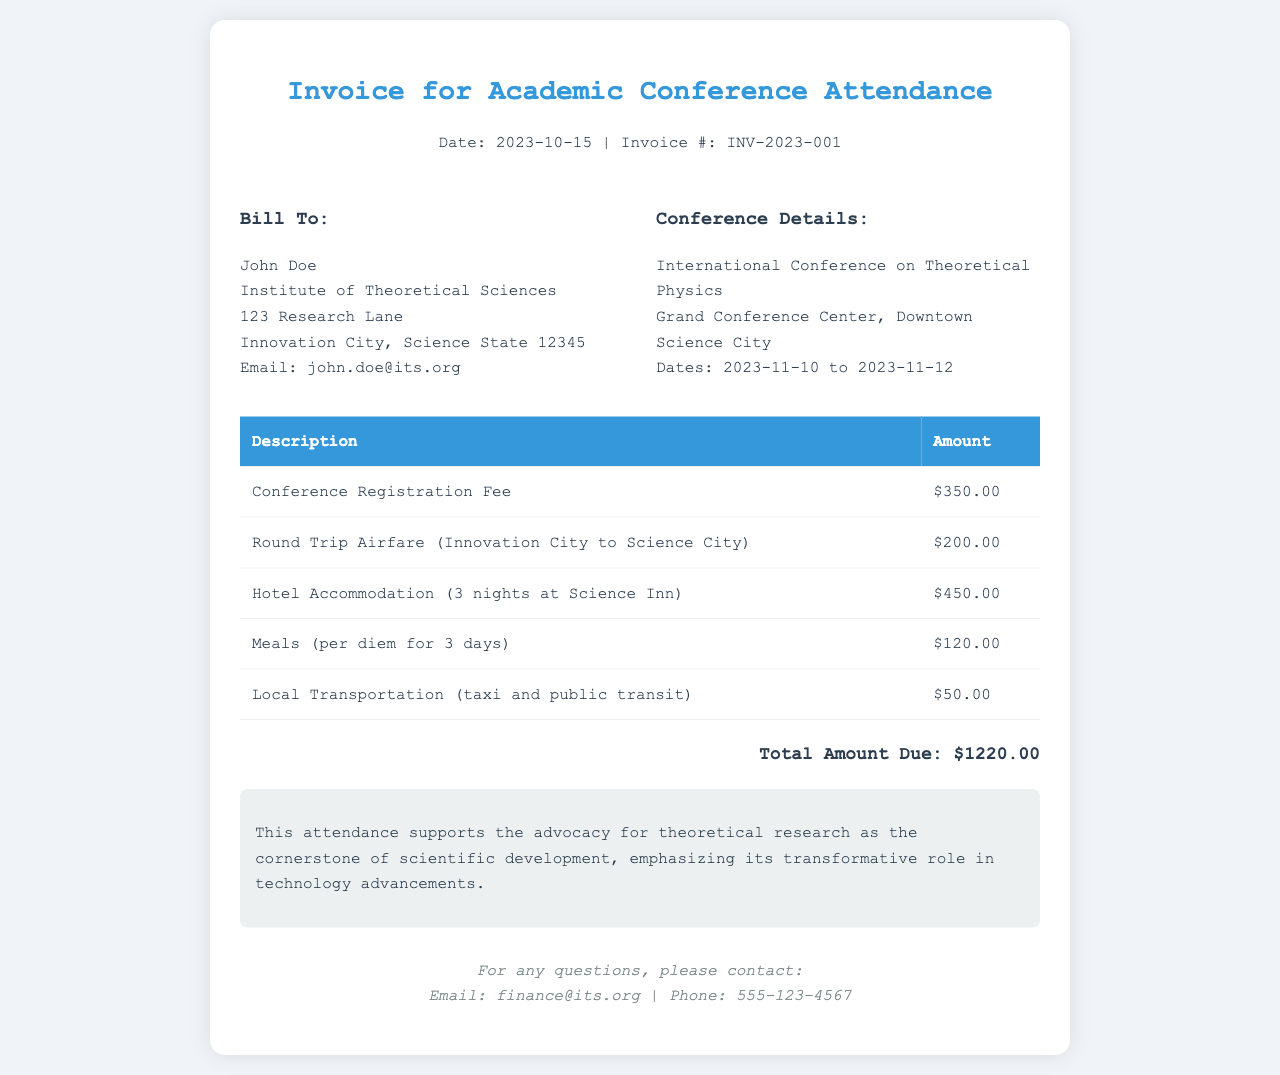What is the invoice number? The invoice number is provided in the document header as INV-2023-001.
Answer: INV-2023-001 What is the total amount due? The total amount due is calculated at the bottom of the invoice as $1220.00.
Answer: $1220.00 Who is the invoice billed to? The billing information includes the person's name and institution, which is John Doe at the Institute of Theoretical Sciences.
Answer: John Doe What are the dates of the conference? The conference dates are specified within the conference details section as 2023-11-10 to 2023-11-12.
Answer: 2023-11-10 to 2023-11-12 How much is the conference registration fee? The registration fee is listed in the itemized expenses as $350.00.
Answer: $350.00 What is emphasized in the note at the bottom? The note explains the importance of theoretical research in science and technology advancements, highlighting its transformative role.
Answer: Theoretical research as cornerstone What is the name of the hotel for accommodations? The document refers to the hotel as Science Inn for the accommodation during the conference.
Answer: Science Inn How many nights is the hotel accommodation for? The hotel accommodation is for 3 nights as indicated under the itemized expenses.
Answer: 3 nights What is the email address provided for questions? The email address for inquiries is provided at the bottom of the invoice as finance@its.org.
Answer: finance@its.org 